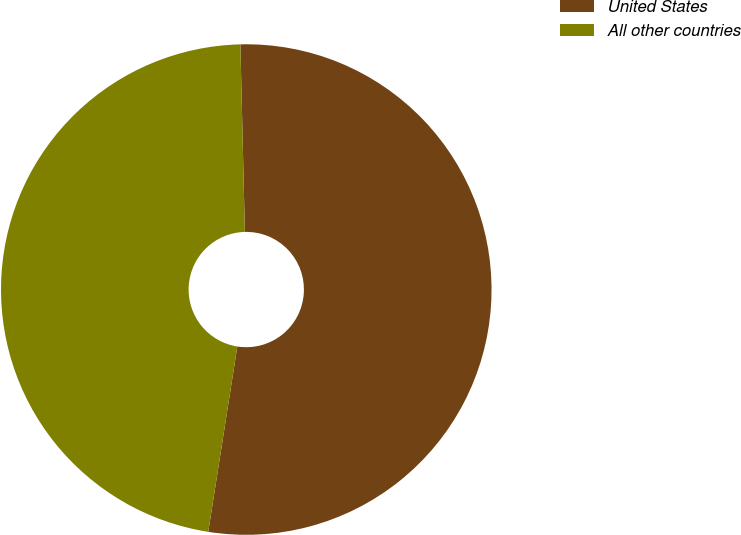Convert chart. <chart><loc_0><loc_0><loc_500><loc_500><pie_chart><fcel>United States<fcel>All other countries<nl><fcel>52.86%<fcel>47.14%<nl></chart> 